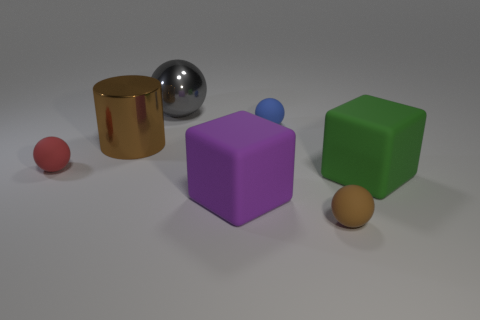What might be the size relation between the objects, based on their shadows? Based on the shadows and their relative lengths and positions, the objects' sizes appear to be proportional to each other, suggesting the cube might be the largest object, with the other shapes decreasing in size respectively. Is there any object that stands out due to color or texture? Yes, the purple cube stands out due to its unique color in contrast to the other objects. Additionally, its matte texture distinguishes it from the reflective surfaces of nearby objects. 